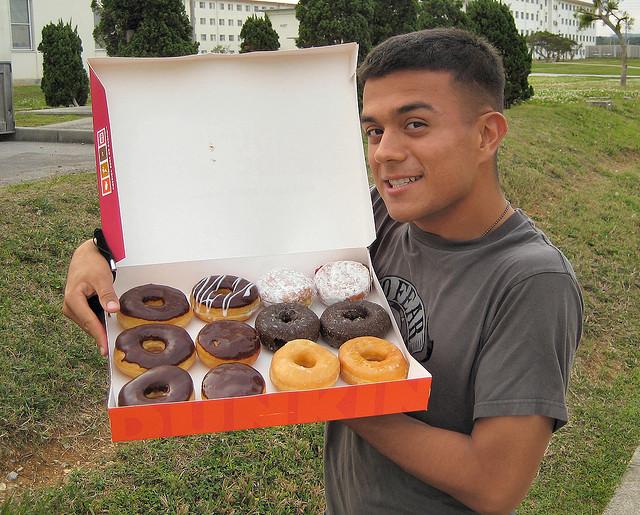Does this man look excited?
Quick response, please. Yes. Is the man wearing glasses?
Give a very brief answer. No. What color is his shirt?
Short answer required. Gray. How many doughnuts is in this box?
Keep it brief. 12. How many people are in the scene?
Concise answer only. 1. What color is the man shirt?
Concise answer only. Gray. How many donuts have holes?
Be succinct. 8. Are all of the donuts the same kind?
Give a very brief answer. No. 